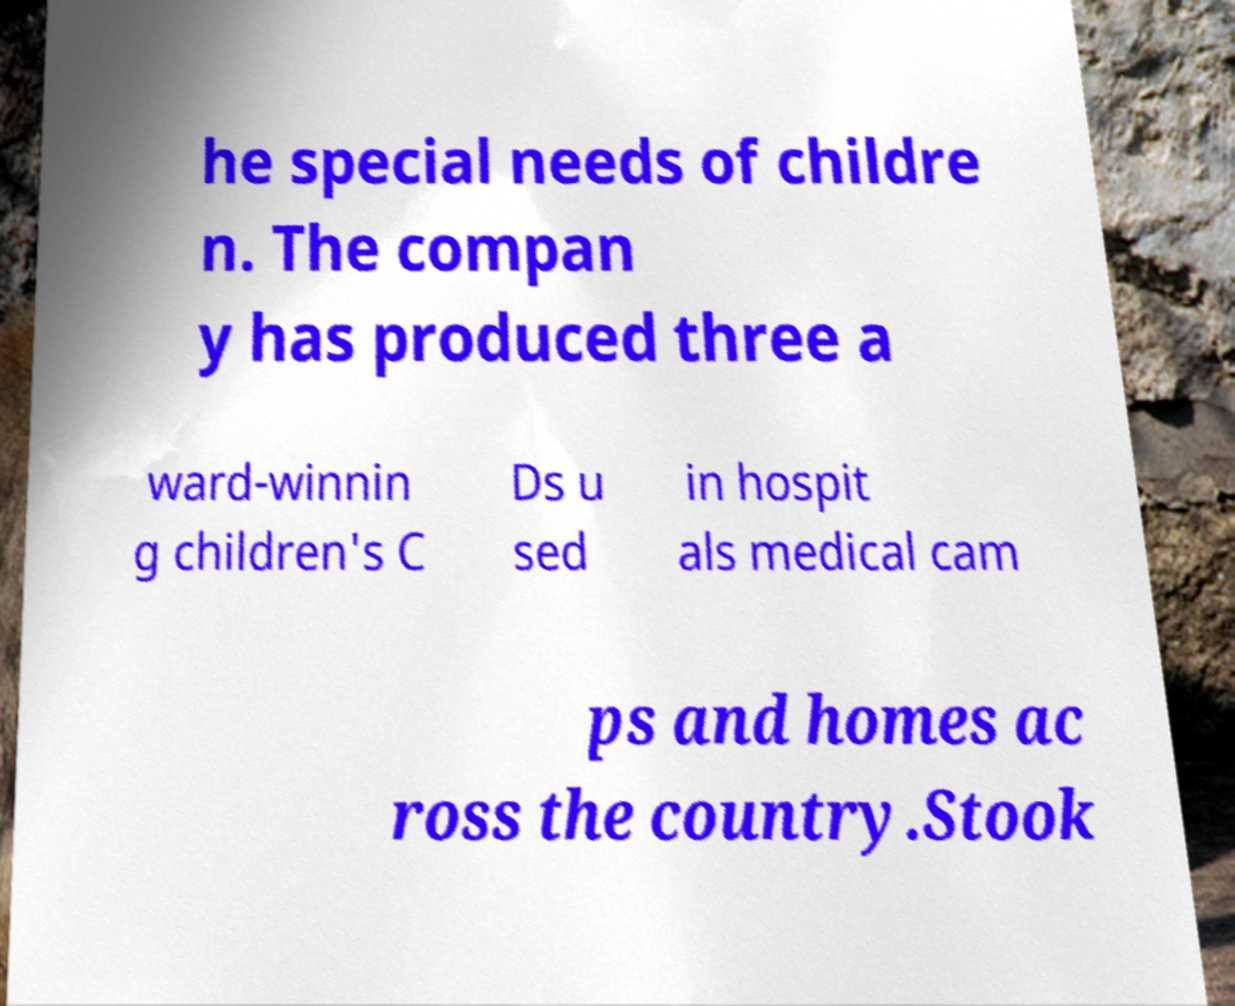Please identify and transcribe the text found in this image. he special needs of childre n. The compan y has produced three a ward-winnin g children's C Ds u sed in hospit als medical cam ps and homes ac ross the country.Stook 